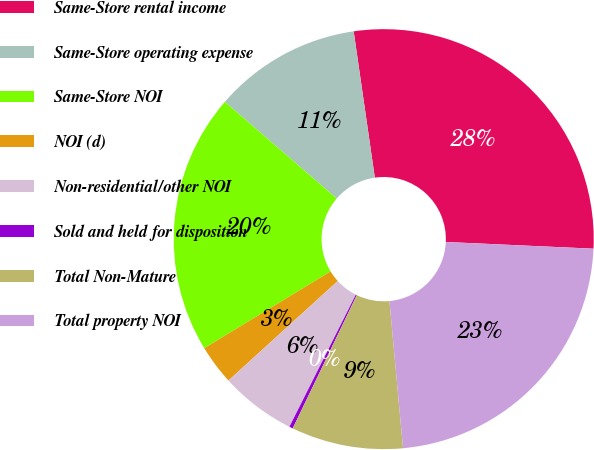Convert chart. <chart><loc_0><loc_0><loc_500><loc_500><pie_chart><fcel>Same-Store rental income<fcel>Same-Store operating expense<fcel>Same-Store NOI<fcel>NOI (d)<fcel>Non-residential/other NOI<fcel>Sold and held for disposition<fcel>Total Non-Mature<fcel>Total property NOI<nl><fcel>28.01%<fcel>11.37%<fcel>20.04%<fcel>3.06%<fcel>5.83%<fcel>0.28%<fcel>8.6%<fcel>22.81%<nl></chart> 